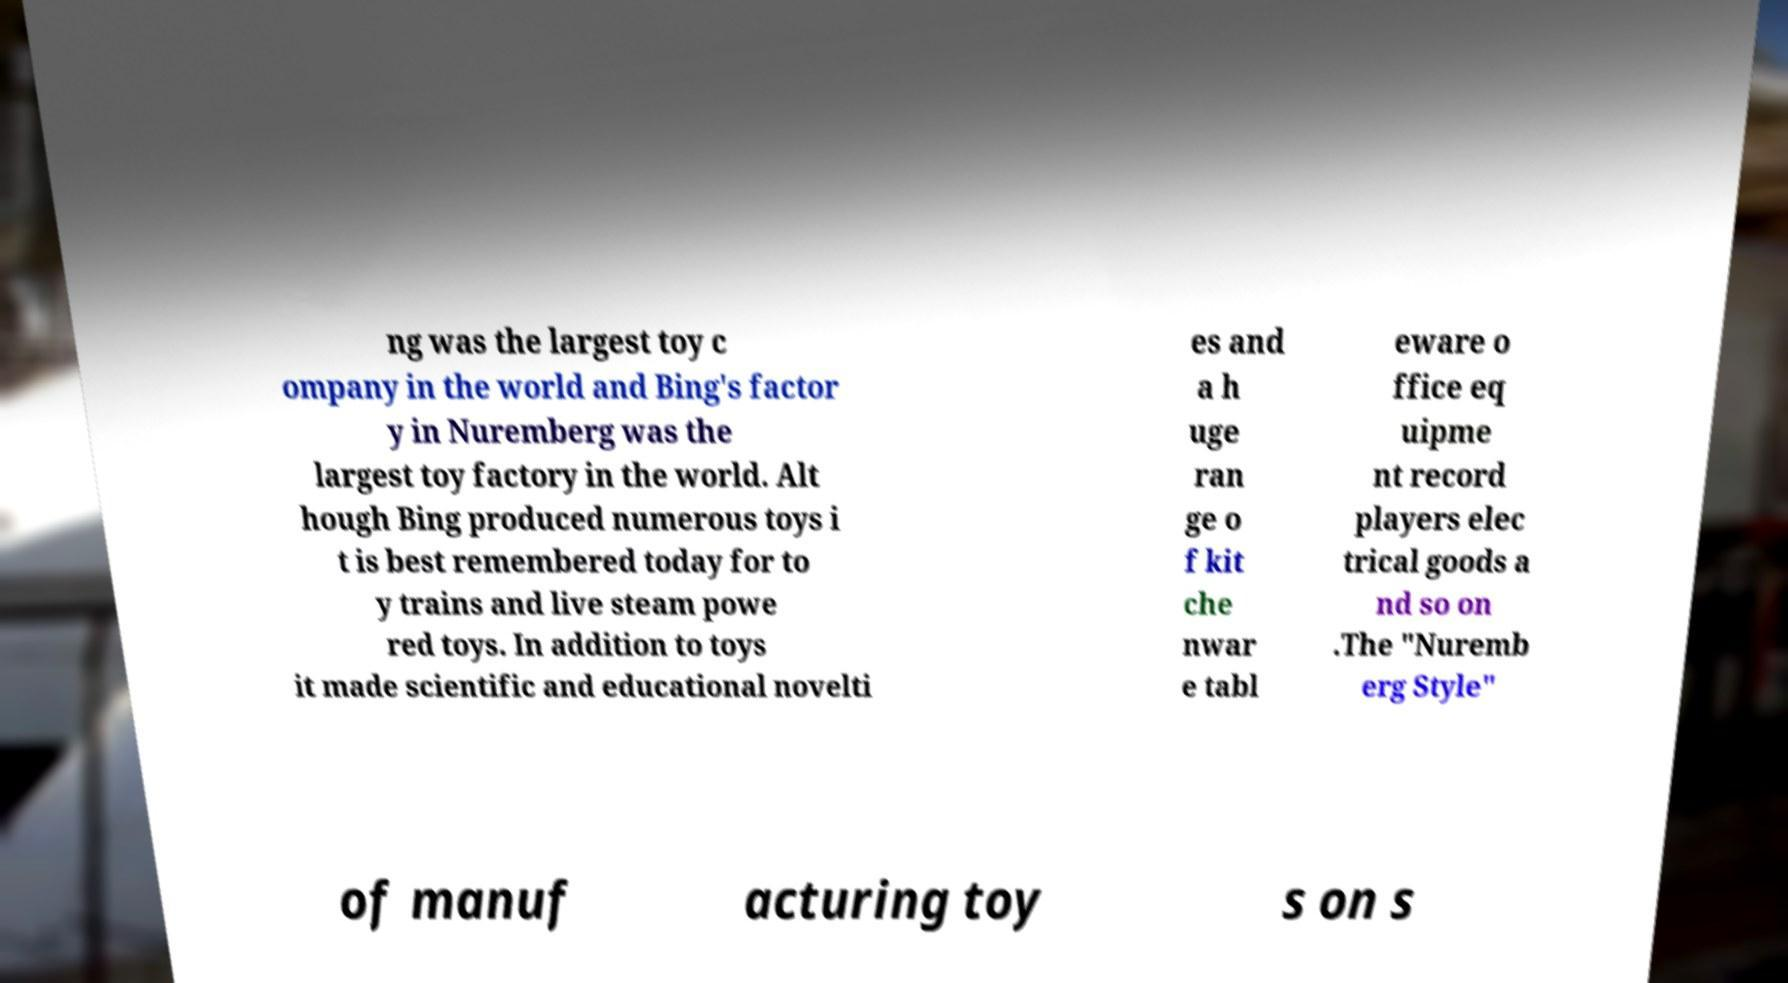There's text embedded in this image that I need extracted. Can you transcribe it verbatim? ng was the largest toy c ompany in the world and Bing's factor y in Nuremberg was the largest toy factory in the world. Alt hough Bing produced numerous toys i t is best remembered today for to y trains and live steam powe red toys. In addition to toys it made scientific and educational novelti es and a h uge ran ge o f kit che nwar e tabl eware o ffice eq uipme nt record players elec trical goods a nd so on .The "Nuremb erg Style" of manuf acturing toy s on s 